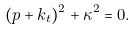<formula> <loc_0><loc_0><loc_500><loc_500>( { p } + { k } _ { t } ) ^ { 2 } + \kappa ^ { 2 } = 0 .</formula> 